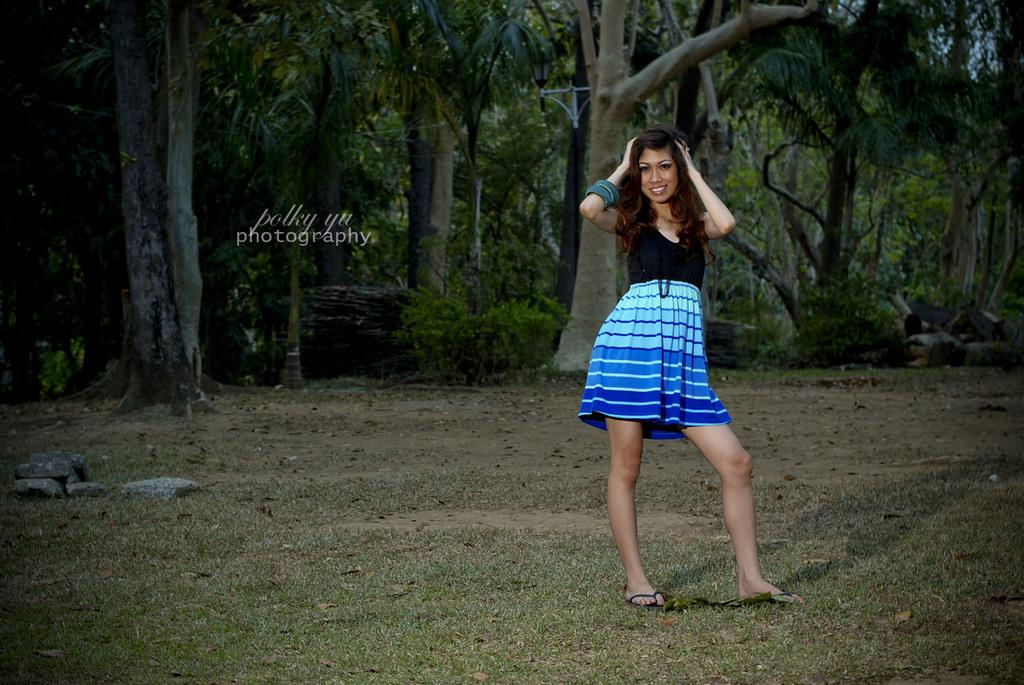Who is present in the image? There is a woman in the image. What is the woman doing in the image? The woman is smiling in the image. What type of surface is the woman standing on? The woman is standing on the grass in the image. What can be seen on the ground in the image? Stones are present on the ground in the image. What is visible in the background of the image? There are trees and some text visible in the background of the image. What type of anger can be seen on the woman's face in the image? The woman is smiling in the image, not showing any signs of anger. What is the texture of the woman's clothing in the image? The provided facts do not mention the texture of the woman's clothing, so we cannot determine it from the image. 